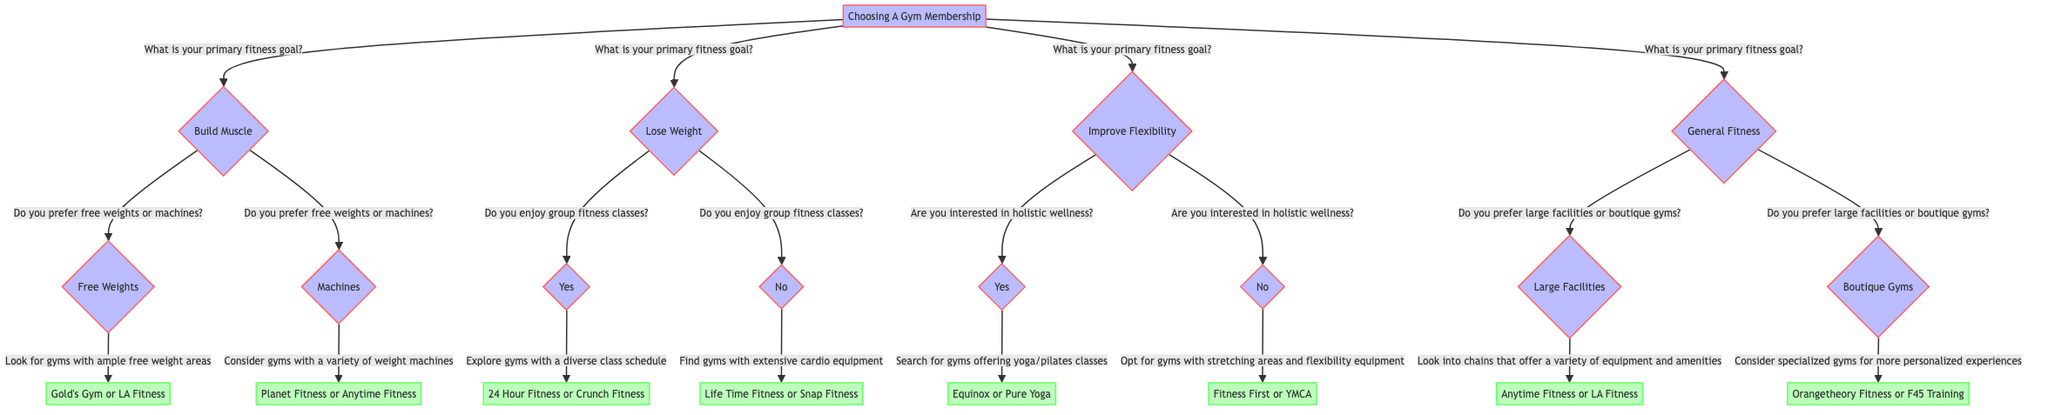What is the primary fitness goal that leads to the question about free weights or machines? The primary fitness goal that leads to the question about free weights or machines is "Build Muscle." This can be identified by following the first question in the diagram and seeing the branching path.
Answer: Build Muscle How many primary fitness goals are presented in the diagram? The diagram presents four primary fitness goals: Build Muscle, Lose Weight, Improve Flexibility, and General Fitness. This can be counted by looking at the first node and identifying the options.
Answer: 4 What option do you get if you prefer boutique gyms? If you prefer boutique gyms, the option you would get is "Consider specialized gyms like Orangetheory Fitness or F45 Training." This can be reached by following the pathways from the "General Fitness" node down to the boutique gyms sub-node.
Answer: Consider specialized gyms like Orangetheory Fitness or F45 Training What is the follow-up question for someone who wants to improve flexibility? The follow-up question for someone who wants to improve flexibility is "Are you interested in holistic wellness (e.g., yoga, pilates)?" This is found by following the path from the "Improve Flexibility" node.
Answer: Are you interested in holistic wellness (e.g., yoga, pilates)? If someone enjoys group fitness classes, which gym options would they explore? If someone enjoys group fitness classes, they would explore gyms with a diverse class schedule such as 24 Hour Fitness or Crunch Fitness. This can be determined by following the path from the "Lose Weight" node and the subsequent question about group classes.
Answer: Explore gyms with a diverse class schedule such as 24 Hour Fitness or Crunch Fitness If a person's primary goal is to lose weight, what will the diagram ask about next? If a person's primary goal is to lose weight, the diagram will ask whether they enjoy group fitness classes. This follows directly from the Lose Weight node in the diagram.
Answer: Do you enjoy group fitness classes? 